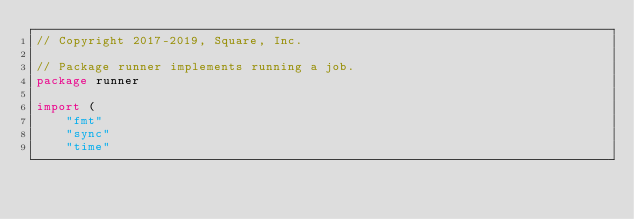Convert code to text. <code><loc_0><loc_0><loc_500><loc_500><_Go_>// Copyright 2017-2019, Square, Inc.

// Package runner implements running a job.
package runner

import (
	"fmt"
	"sync"
	"time"
</code> 